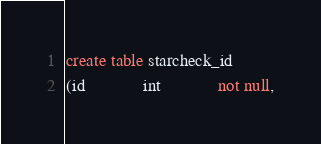Convert code to text. <code><loc_0><loc_0><loc_500><loc_500><_SQL_>create table starcheck_id
(id             int             not null,</code> 